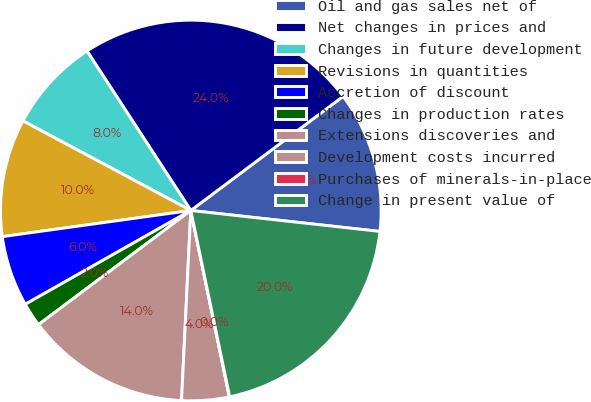<chart> <loc_0><loc_0><loc_500><loc_500><pie_chart><fcel>Oil and gas sales net of<fcel>Net changes in prices and<fcel>Changes in future development<fcel>Revisions in quantities<fcel>Accretion of discount<fcel>Changes in production rates<fcel>Extensions discoveries and<fcel>Development costs incurred<fcel>Purchases of minerals-in-place<fcel>Change in present value of<nl><fcel>11.99%<fcel>23.95%<fcel>8.01%<fcel>10.0%<fcel>6.01%<fcel>2.03%<fcel>13.99%<fcel>4.02%<fcel>0.03%<fcel>19.97%<nl></chart> 